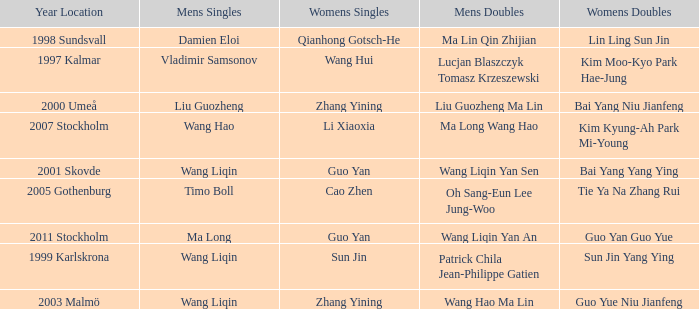What is the place and when was the year when the women's doubles womens were Bai yang Niu Jianfeng? 2000 Umeå. 